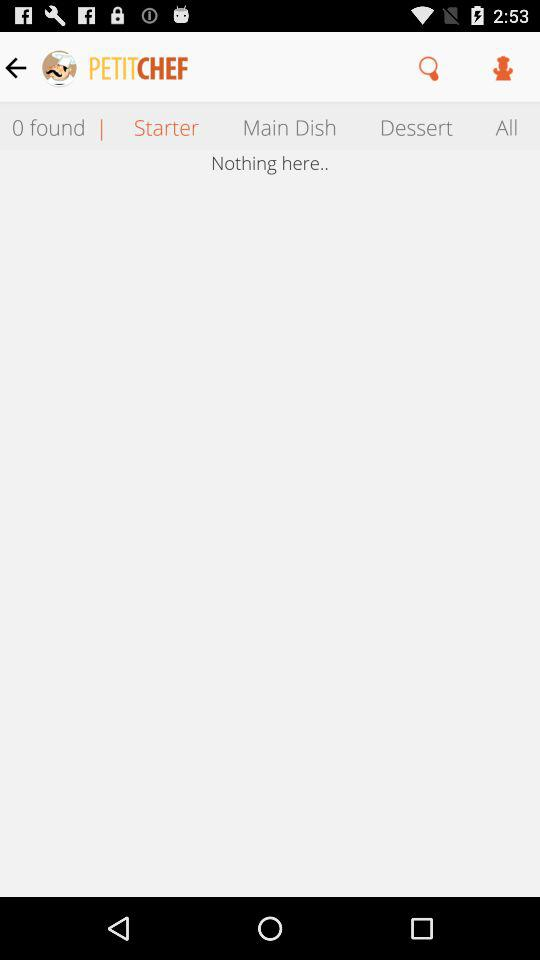Which tab is selected? The selected tab is "Starter". 